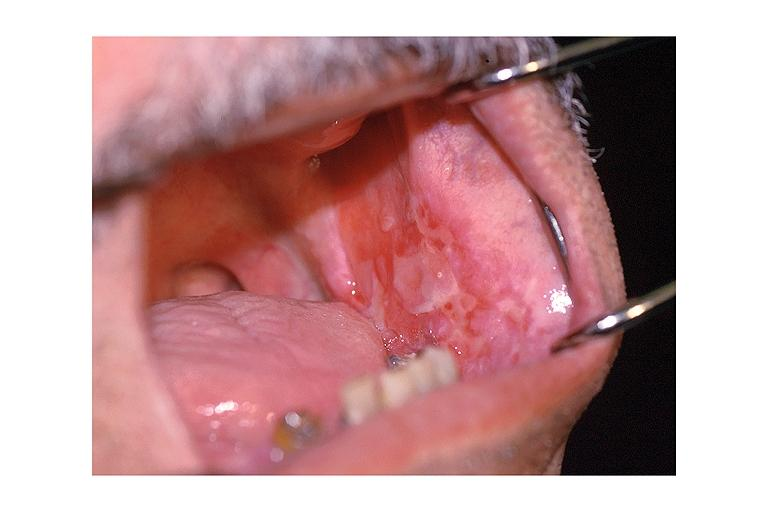what is present?
Answer the question using a single word or phrase. Oral 